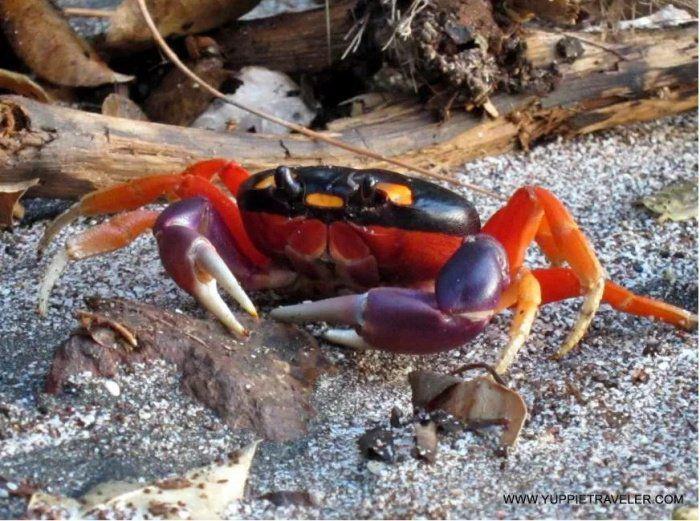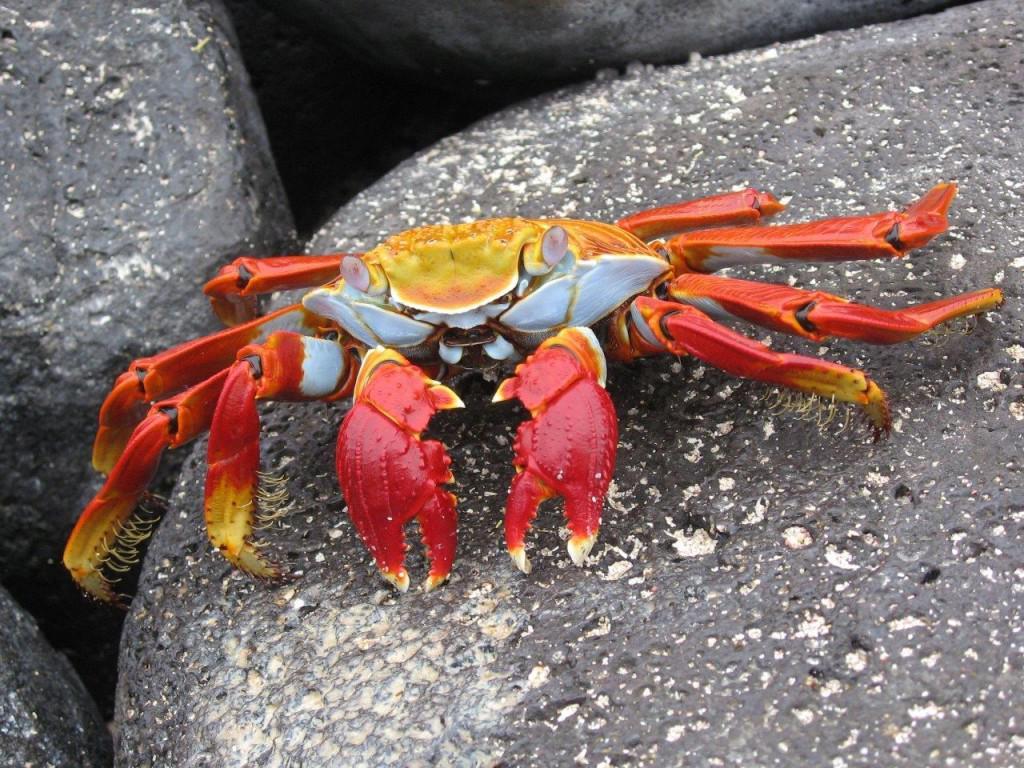The first image is the image on the left, the second image is the image on the right. Examine the images to the left and right. Is the description "The righthand image shows a blue-and-yellow faced crab with its two red front claws turned downward and perched on rock." accurate? Answer yes or no. Yes. The first image is the image on the left, the second image is the image on the right. Assess this claim about the two images: "The left and right image contains the same number of crabs standing on land.". Correct or not? Answer yes or no. Yes. 